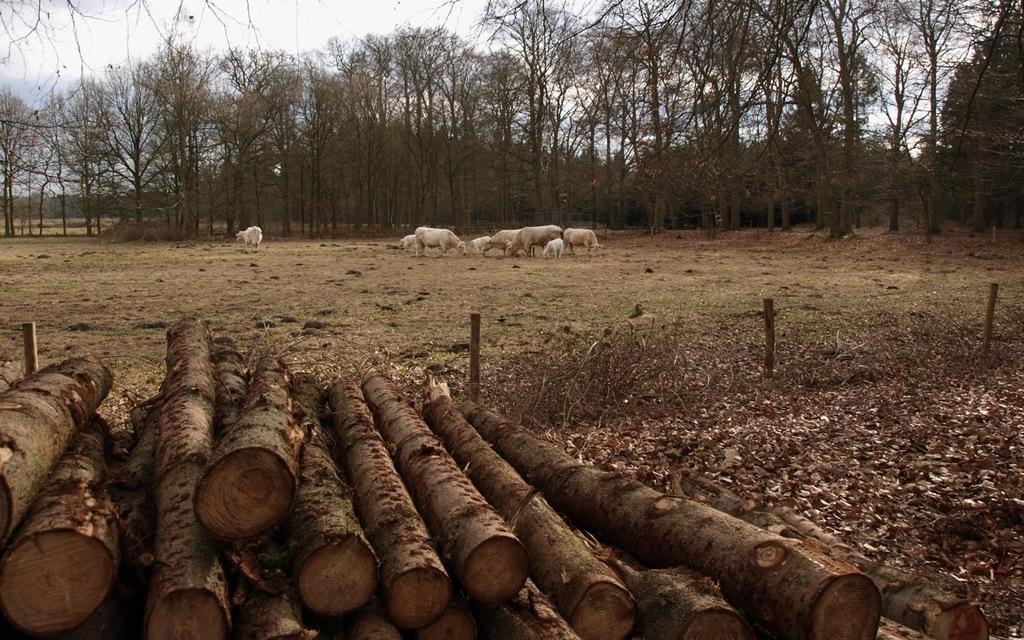Please provide a concise description of this image. In this image we can see wooden logs. Also there are poles. In the back there are animals. Also there are trees. In the background there is sky. 